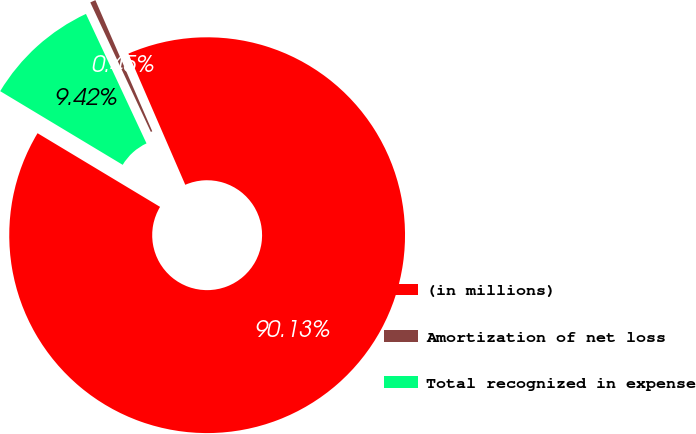Convert chart to OTSL. <chart><loc_0><loc_0><loc_500><loc_500><pie_chart><fcel>(in millions)<fcel>Amortization of net loss<fcel>Total recognized in expense<nl><fcel>90.13%<fcel>0.45%<fcel>9.42%<nl></chart> 